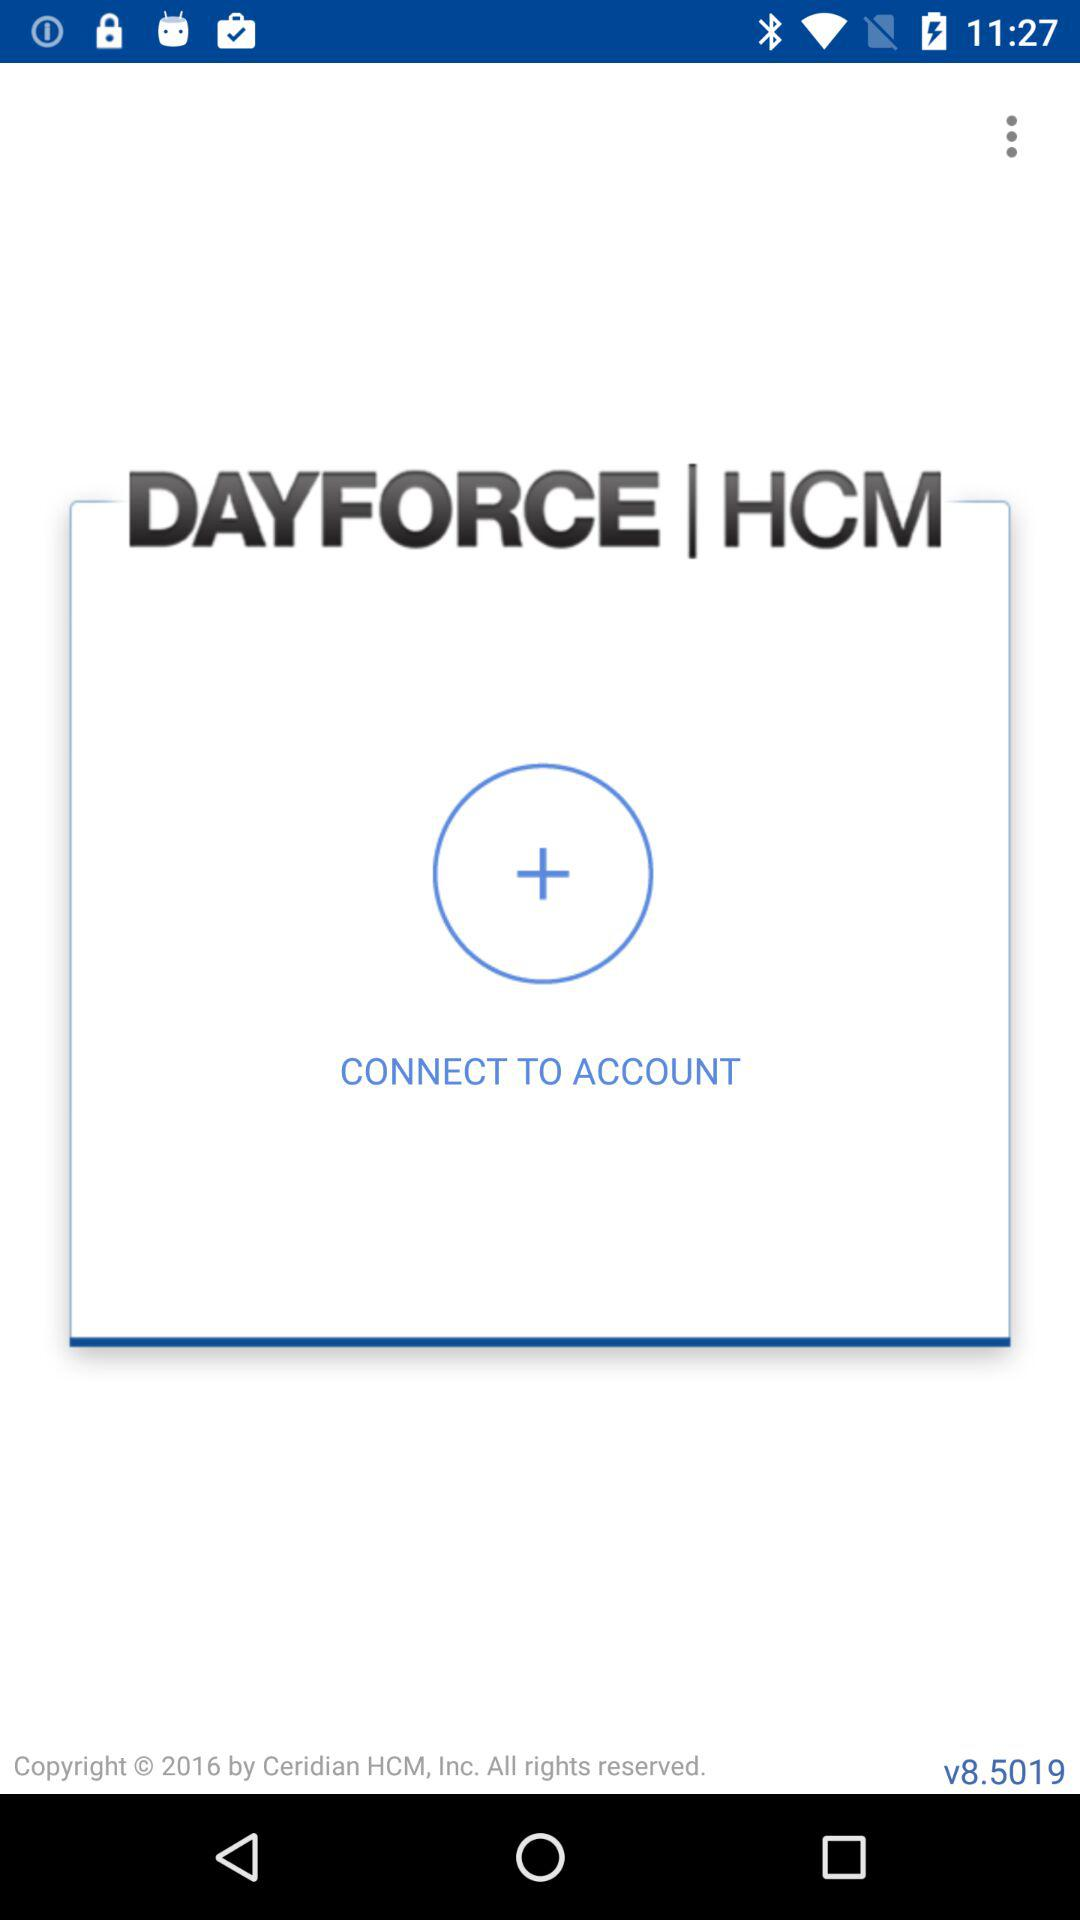What is the version of application being used? The version is v8.5019. 